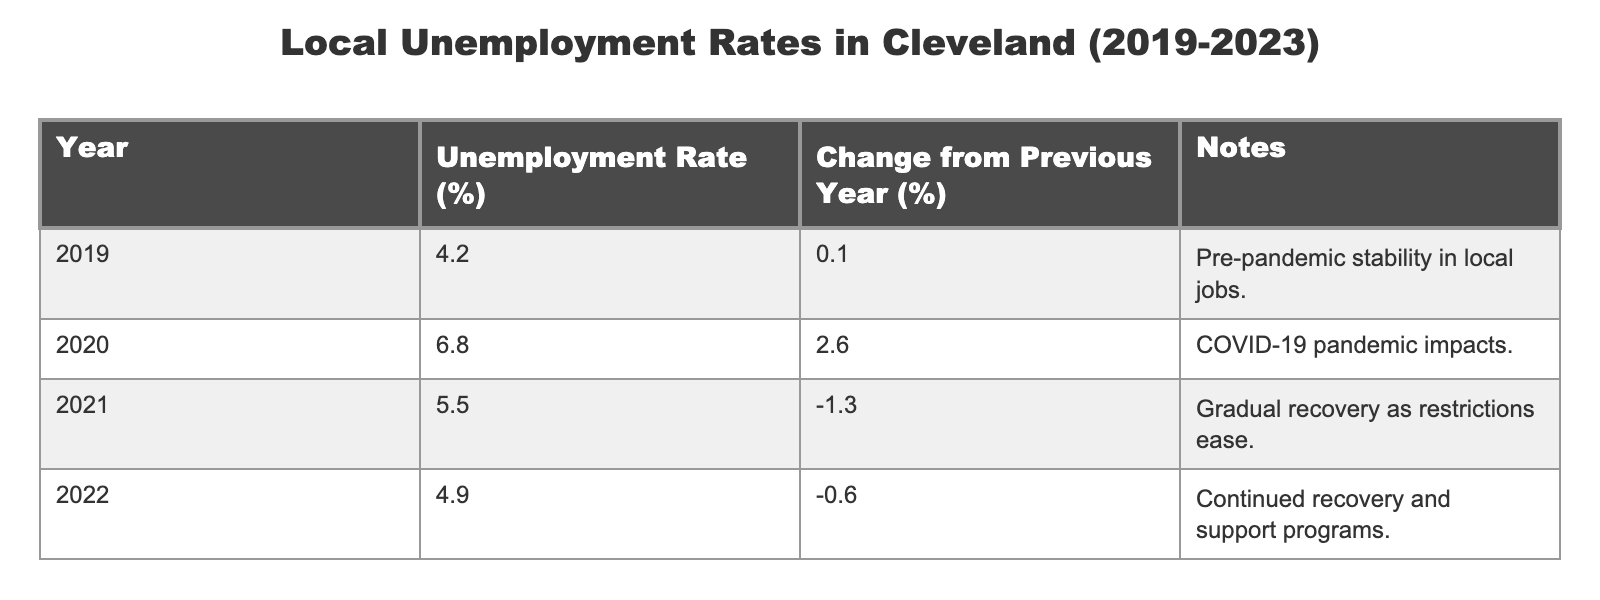What was the unemployment rate in Cleveland in 2019? The table clearly shows that the unemployment rate for the year 2019 was 4.2%.
Answer: 4.2% What is the change in the unemployment rate from 2020 to 2021? In 2020, the unemployment rate was 6.8%, while in 2021 it decreased to 5.5%. The change is 6.8% - 5.5% = 1.3%.
Answer: 1.3% Was there an increase in unemployment rates from 2019 to 2020? Comparing the two years, the rate in 2019 was 4.2% and it rose to 6.8% in 2020, indicating an increase.
Answer: Yes In which year did the unemployment rate drop the most compared to the previous year? Looking at the changes: from 2019 to 2020, the change was +2.6%; from 2020 to 2021, it was -1.3%; from 2021 to 2022, it was -0.6%; and from 2022 to 2023, it was -0.6%. The largest drop occurred from 2020 to 2021 with a decrease of 1.3%.
Answer: 2020 to 2021 What was the average unemployment rate over the five years? To find the average, sum the rates (4.2% + 6.8% + 5.5% + 4.9% + 4.3% = 25.7%) and divide by 5. The average is 25.7% / 5 = 5.14%.
Answer: 5.14% Was the unemployment rate in 2022 higher than in 2021? The unemployment rate in 2021 was 5.5%, while in 2022 it was 4.9%, indicating a decrease.
Answer: No What trend is observed in the unemployment rates from 2019 to 2023? From 2019 to 2020, there was an increase, then a decrease from 2020 to 2021, a small decrease from 2021 to 2022, and a slight drop again from 2022 to 2023. Overall, the trend shows recovery after the spike in 2020.
Answer: Recovery trend What was the unemployment rate in 2023 compared to 2019? The unemployment rate in 2023 is 4.3%, while in 2019 it was 4.2%. The rate in 2023 is slightly higher than in 2019.
Answer: Higher 